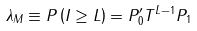<formula> <loc_0><loc_0><loc_500><loc_500>\lambda _ { M } \equiv P \left ( \| I \| \geq L \right ) = P ^ { \prime } _ { 0 } T ^ { L - 1 } P _ { 1 }</formula> 